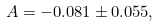Convert formula to latex. <formula><loc_0><loc_0><loc_500><loc_500>A = - 0 . 0 8 1 \pm 0 . 0 5 5 ,</formula> 